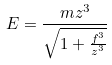<formula> <loc_0><loc_0><loc_500><loc_500>E = \frac { m z ^ { 3 } } { \sqrt { 1 + \frac { f ^ { 3 } } { z ^ { 3 } } } }</formula> 